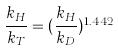<formula> <loc_0><loc_0><loc_500><loc_500>\frac { k _ { H } } { k _ { T } } = ( \frac { k _ { H } } { k _ { D } } ) ^ { 1 . 4 4 2 }</formula> 